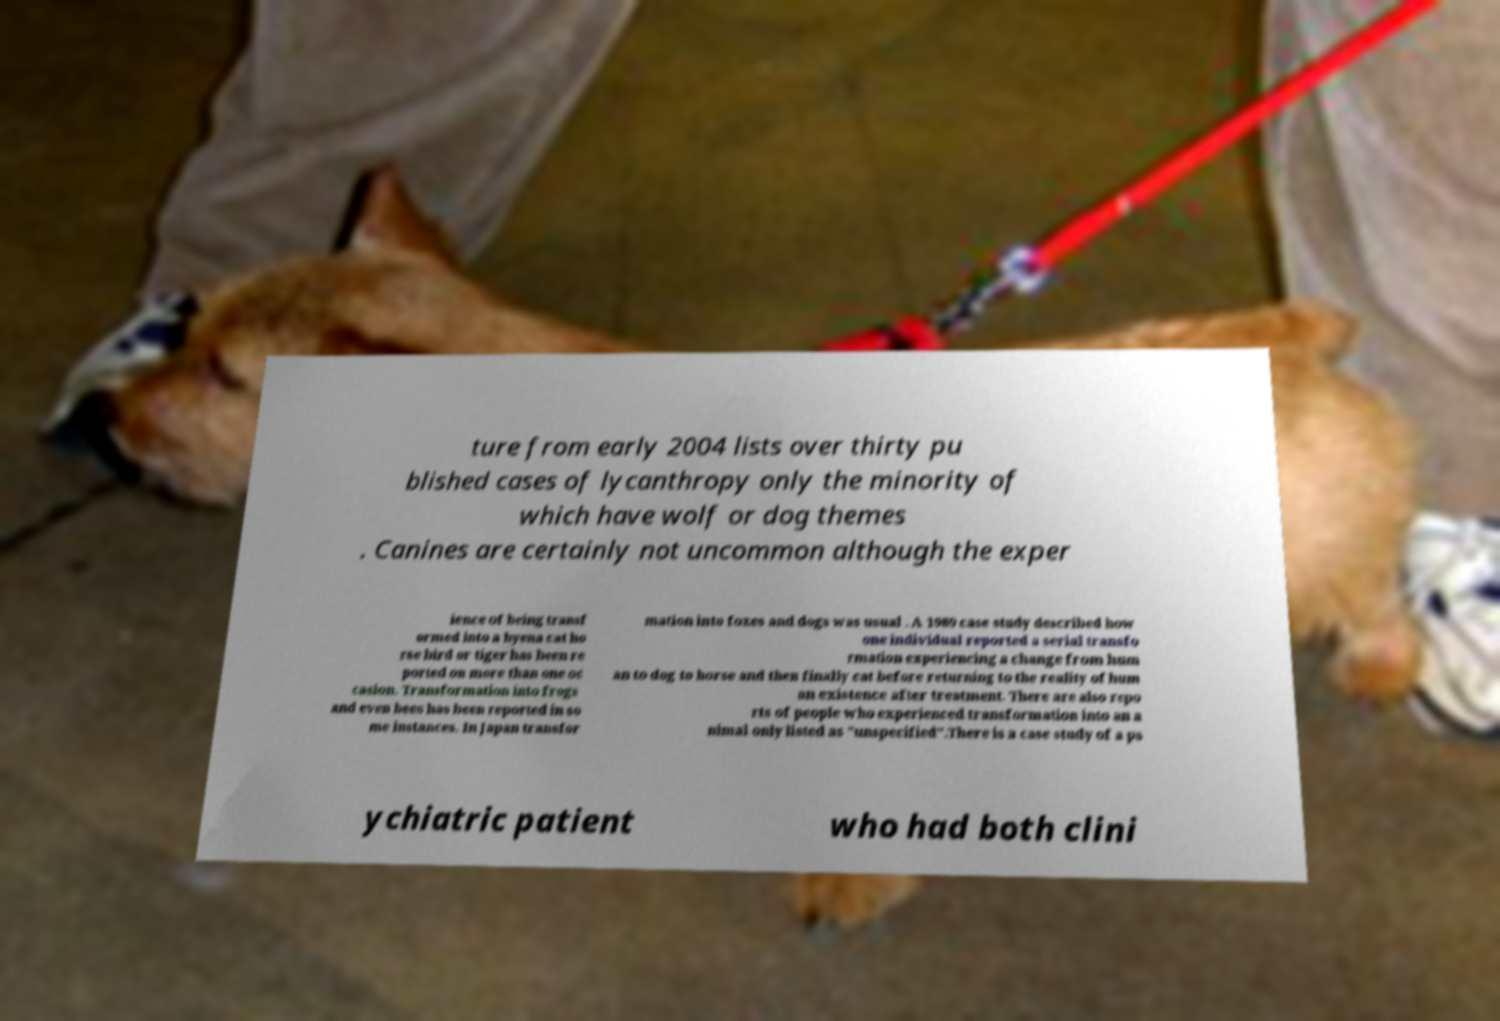Could you extract and type out the text from this image? ture from early 2004 lists over thirty pu blished cases of lycanthropy only the minority of which have wolf or dog themes . Canines are certainly not uncommon although the exper ience of being transf ormed into a hyena cat ho rse bird or tiger has been re ported on more than one oc casion. Transformation into frogs and even bees has been reported in so me instances. In Japan transfor mation into foxes and dogs was usual . A 1989 case study described how one individual reported a serial transfo rmation experiencing a change from hum an to dog to horse and then finally cat before returning to the reality of hum an existence after treatment. There are also repo rts of people who experienced transformation into an a nimal only listed as "unspecified".There is a case study of a ps ychiatric patient who had both clini 